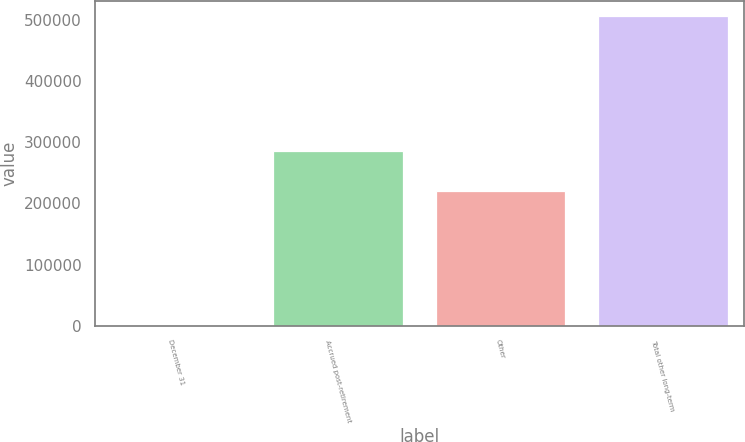<chart> <loc_0><loc_0><loc_500><loc_500><bar_chart><fcel>December 31<fcel>Accrued post-retirement<fcel>Other<fcel>Total other long-term<nl><fcel>2008<fcel>285001<fcel>219962<fcel>504963<nl></chart> 